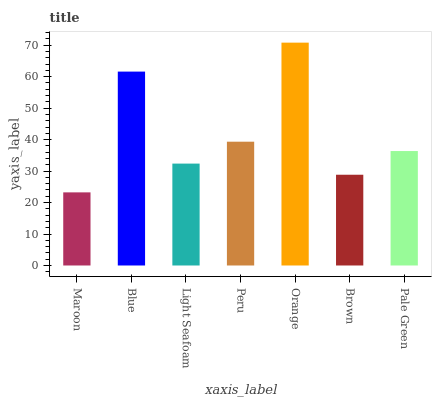Is Maroon the minimum?
Answer yes or no. Yes. Is Orange the maximum?
Answer yes or no. Yes. Is Blue the minimum?
Answer yes or no. No. Is Blue the maximum?
Answer yes or no. No. Is Blue greater than Maroon?
Answer yes or no. Yes. Is Maroon less than Blue?
Answer yes or no. Yes. Is Maroon greater than Blue?
Answer yes or no. No. Is Blue less than Maroon?
Answer yes or no. No. Is Pale Green the high median?
Answer yes or no. Yes. Is Pale Green the low median?
Answer yes or no. Yes. Is Brown the high median?
Answer yes or no. No. Is Peru the low median?
Answer yes or no. No. 